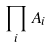Convert formula to latex. <formula><loc_0><loc_0><loc_500><loc_500>\prod _ { i } A _ { i }</formula> 